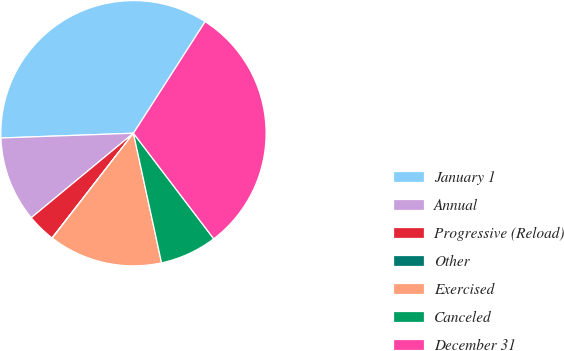<chart> <loc_0><loc_0><loc_500><loc_500><pie_chart><fcel>January 1<fcel>Annual<fcel>Progressive (Reload)<fcel>Other<fcel>Exercised<fcel>Canceled<fcel>December 31<nl><fcel>34.66%<fcel>10.42%<fcel>3.49%<fcel>0.03%<fcel>13.88%<fcel>6.95%<fcel>30.56%<nl></chart> 